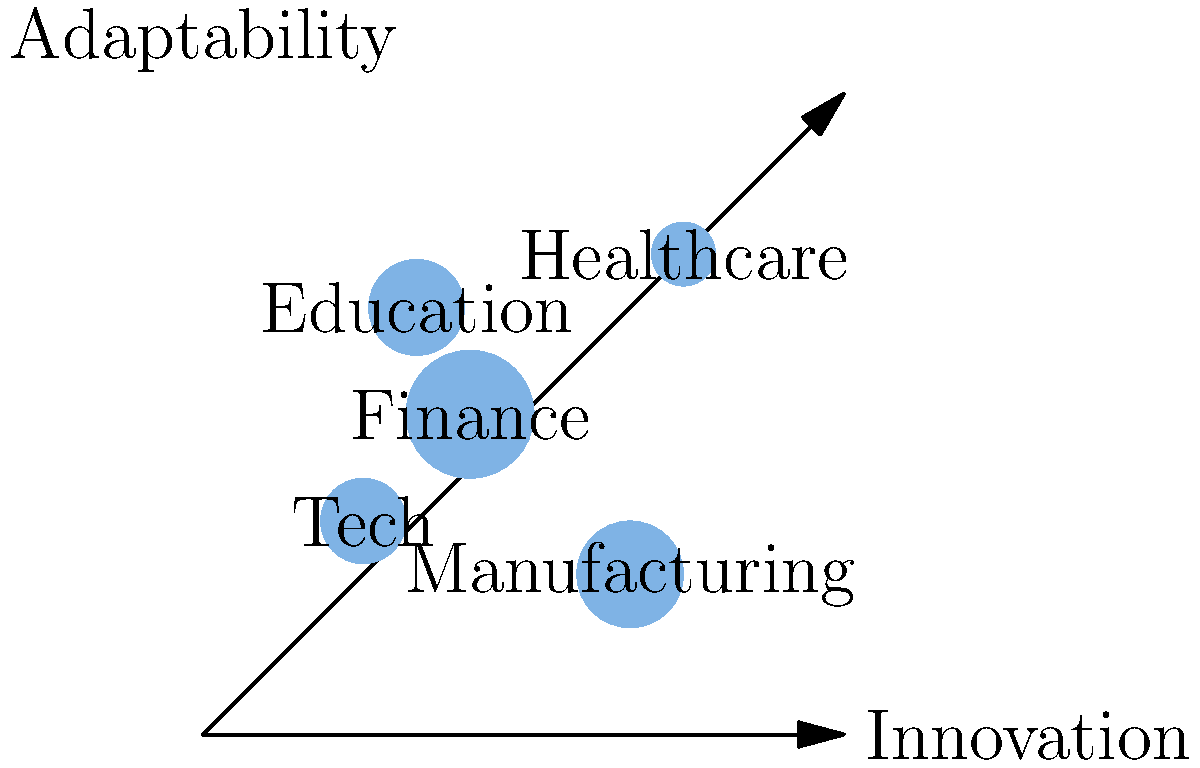Based on the bubble chart illustrating the distribution of leadership traits across different industries, which industry appears to have the highest combination of innovation and adaptability? To answer this question, we need to analyze the position and size of each bubble in the chart:

1. The x-axis represents innovation, while the y-axis represents adaptability.
2. The size of each bubble indicates the relative importance or prevalence of leadership in that industry.

Let's examine each industry:

1. Tech: Moderate innovation and adaptability, medium-sized bubble
2. Finance: High innovation and adaptability, large bubble
3. Manufacturing: High innovation but low adaptability, medium-sized bubble
4. Healthcare: Very high innovation and adaptability, small bubble
5. Education: Low innovation but high adaptability, medium-sized bubble

The industry with the highest combination of innovation and adaptability would be positioned towards the top-right corner of the chart. In this case, the Finance industry bubble is located in the upper-right quadrant and has the largest size, indicating a strong presence of leadership traits.

While Healthcare appears to have slightly higher scores in both innovation and adaptability, its smaller bubble size suggests that leadership traits may not be as prevalent or impactful in this industry compared to Finance.

Therefore, considering both the position (high scores in innovation and adaptability) and the bubble size (indicating strong leadership presence), the Finance industry demonstrates the highest combination of these leadership traits.
Answer: Finance 